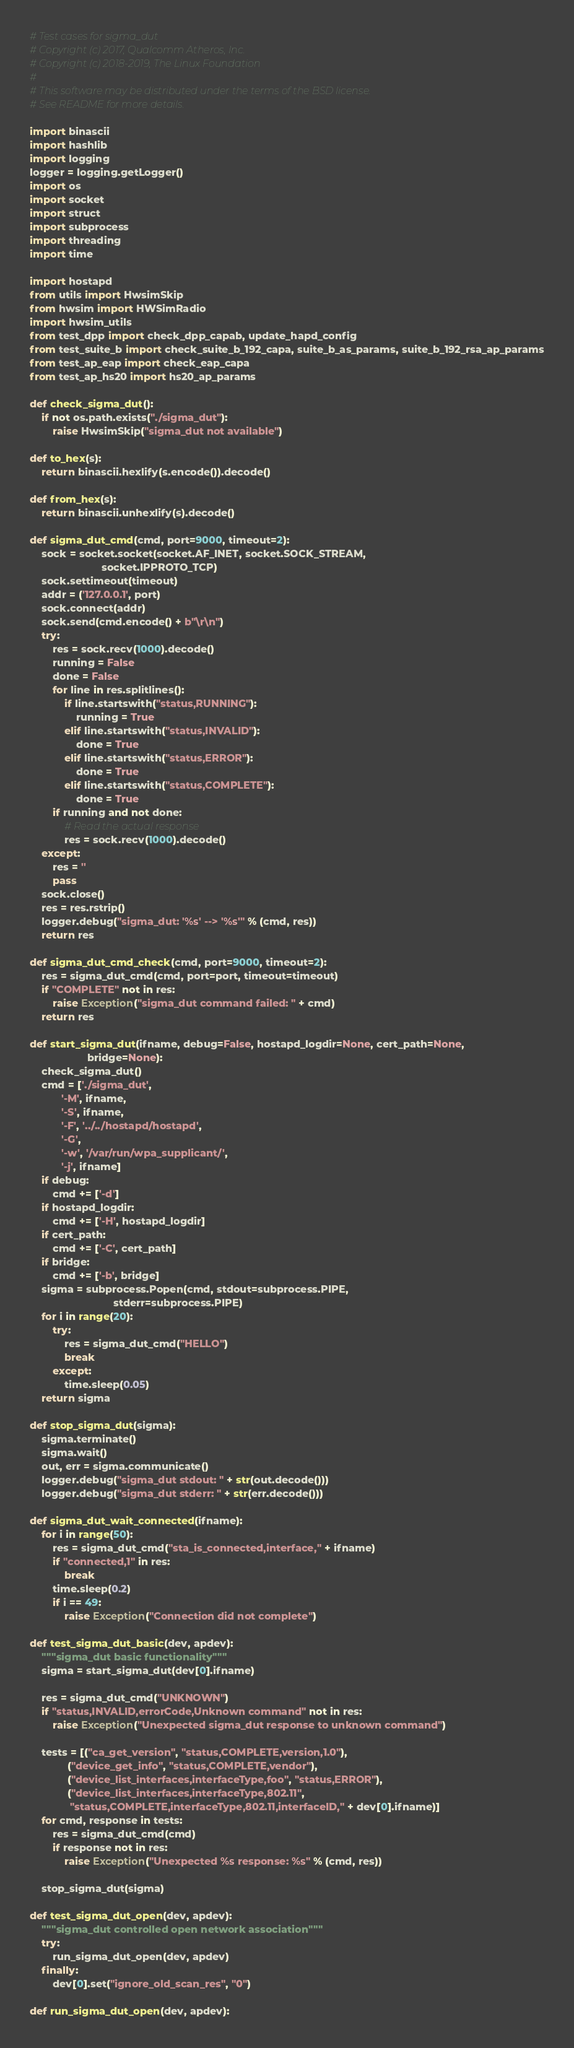Convert code to text. <code><loc_0><loc_0><loc_500><loc_500><_Python_># Test cases for sigma_dut
# Copyright (c) 2017, Qualcomm Atheros, Inc.
# Copyright (c) 2018-2019, The Linux Foundation
#
# This software may be distributed under the terms of the BSD license.
# See README for more details.

import binascii
import hashlib
import logging
logger = logging.getLogger()
import os
import socket
import struct
import subprocess
import threading
import time

import hostapd
from utils import HwsimSkip
from hwsim import HWSimRadio
import hwsim_utils
from test_dpp import check_dpp_capab, update_hapd_config
from test_suite_b import check_suite_b_192_capa, suite_b_as_params, suite_b_192_rsa_ap_params
from test_ap_eap import check_eap_capa
from test_ap_hs20 import hs20_ap_params

def check_sigma_dut():
    if not os.path.exists("./sigma_dut"):
        raise HwsimSkip("sigma_dut not available")

def to_hex(s):
    return binascii.hexlify(s.encode()).decode()

def from_hex(s):
    return binascii.unhexlify(s).decode()

def sigma_dut_cmd(cmd, port=9000, timeout=2):
    sock = socket.socket(socket.AF_INET, socket.SOCK_STREAM,
                         socket.IPPROTO_TCP)
    sock.settimeout(timeout)
    addr = ('127.0.0.1', port)
    sock.connect(addr)
    sock.send(cmd.encode() + b"\r\n")
    try:
        res = sock.recv(1000).decode()
        running = False
        done = False
        for line in res.splitlines():
            if line.startswith("status,RUNNING"):
                running = True
            elif line.startswith("status,INVALID"):
                done = True
            elif line.startswith("status,ERROR"):
                done = True
            elif line.startswith("status,COMPLETE"):
                done = True
        if running and not done:
            # Read the actual response
            res = sock.recv(1000).decode()
    except:
        res = ''
        pass
    sock.close()
    res = res.rstrip()
    logger.debug("sigma_dut: '%s' --> '%s'" % (cmd, res))
    return res

def sigma_dut_cmd_check(cmd, port=9000, timeout=2):
    res = sigma_dut_cmd(cmd, port=port, timeout=timeout)
    if "COMPLETE" not in res:
        raise Exception("sigma_dut command failed: " + cmd)
    return res

def start_sigma_dut(ifname, debug=False, hostapd_logdir=None, cert_path=None,
                    bridge=None):
    check_sigma_dut()
    cmd = ['./sigma_dut',
           '-M', ifname,
           '-S', ifname,
           '-F', '../../hostapd/hostapd',
           '-G',
           '-w', '/var/run/wpa_supplicant/',
           '-j', ifname]
    if debug:
        cmd += ['-d']
    if hostapd_logdir:
        cmd += ['-H', hostapd_logdir]
    if cert_path:
        cmd += ['-C', cert_path]
    if bridge:
        cmd += ['-b', bridge]
    sigma = subprocess.Popen(cmd, stdout=subprocess.PIPE,
                             stderr=subprocess.PIPE)
    for i in range(20):
        try:
            res = sigma_dut_cmd("HELLO")
            break
        except:
            time.sleep(0.05)
    return sigma

def stop_sigma_dut(sigma):
    sigma.terminate()
    sigma.wait()
    out, err = sigma.communicate()
    logger.debug("sigma_dut stdout: " + str(out.decode()))
    logger.debug("sigma_dut stderr: " + str(err.decode()))

def sigma_dut_wait_connected(ifname):
    for i in range(50):
        res = sigma_dut_cmd("sta_is_connected,interface," + ifname)
        if "connected,1" in res:
            break
        time.sleep(0.2)
        if i == 49:
            raise Exception("Connection did not complete")

def test_sigma_dut_basic(dev, apdev):
    """sigma_dut basic functionality"""
    sigma = start_sigma_dut(dev[0].ifname)

    res = sigma_dut_cmd("UNKNOWN")
    if "status,INVALID,errorCode,Unknown command" not in res:
        raise Exception("Unexpected sigma_dut response to unknown command")

    tests = [("ca_get_version", "status,COMPLETE,version,1.0"),
             ("device_get_info", "status,COMPLETE,vendor"),
             ("device_list_interfaces,interfaceType,foo", "status,ERROR"),
             ("device_list_interfaces,interfaceType,802.11",
              "status,COMPLETE,interfaceType,802.11,interfaceID," + dev[0].ifname)]
    for cmd, response in tests:
        res = sigma_dut_cmd(cmd)
        if response not in res:
            raise Exception("Unexpected %s response: %s" % (cmd, res))

    stop_sigma_dut(sigma)

def test_sigma_dut_open(dev, apdev):
    """sigma_dut controlled open network association"""
    try:
        run_sigma_dut_open(dev, apdev)
    finally:
        dev[0].set("ignore_old_scan_res", "0")

def run_sigma_dut_open(dev, apdev):</code> 